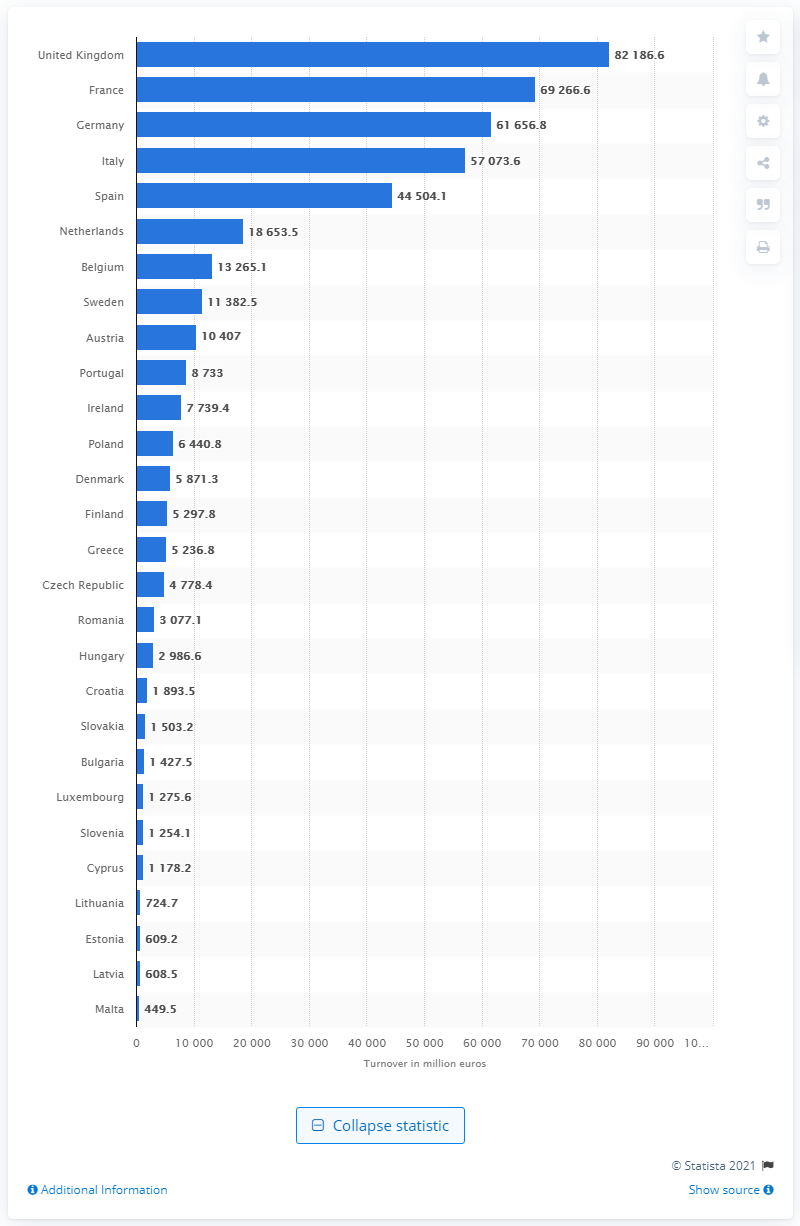Outline some significant characteristics in this image. In 2017, the provisional turnover of food and beverage serving enterprises in the UK was £82,186.6 million. 